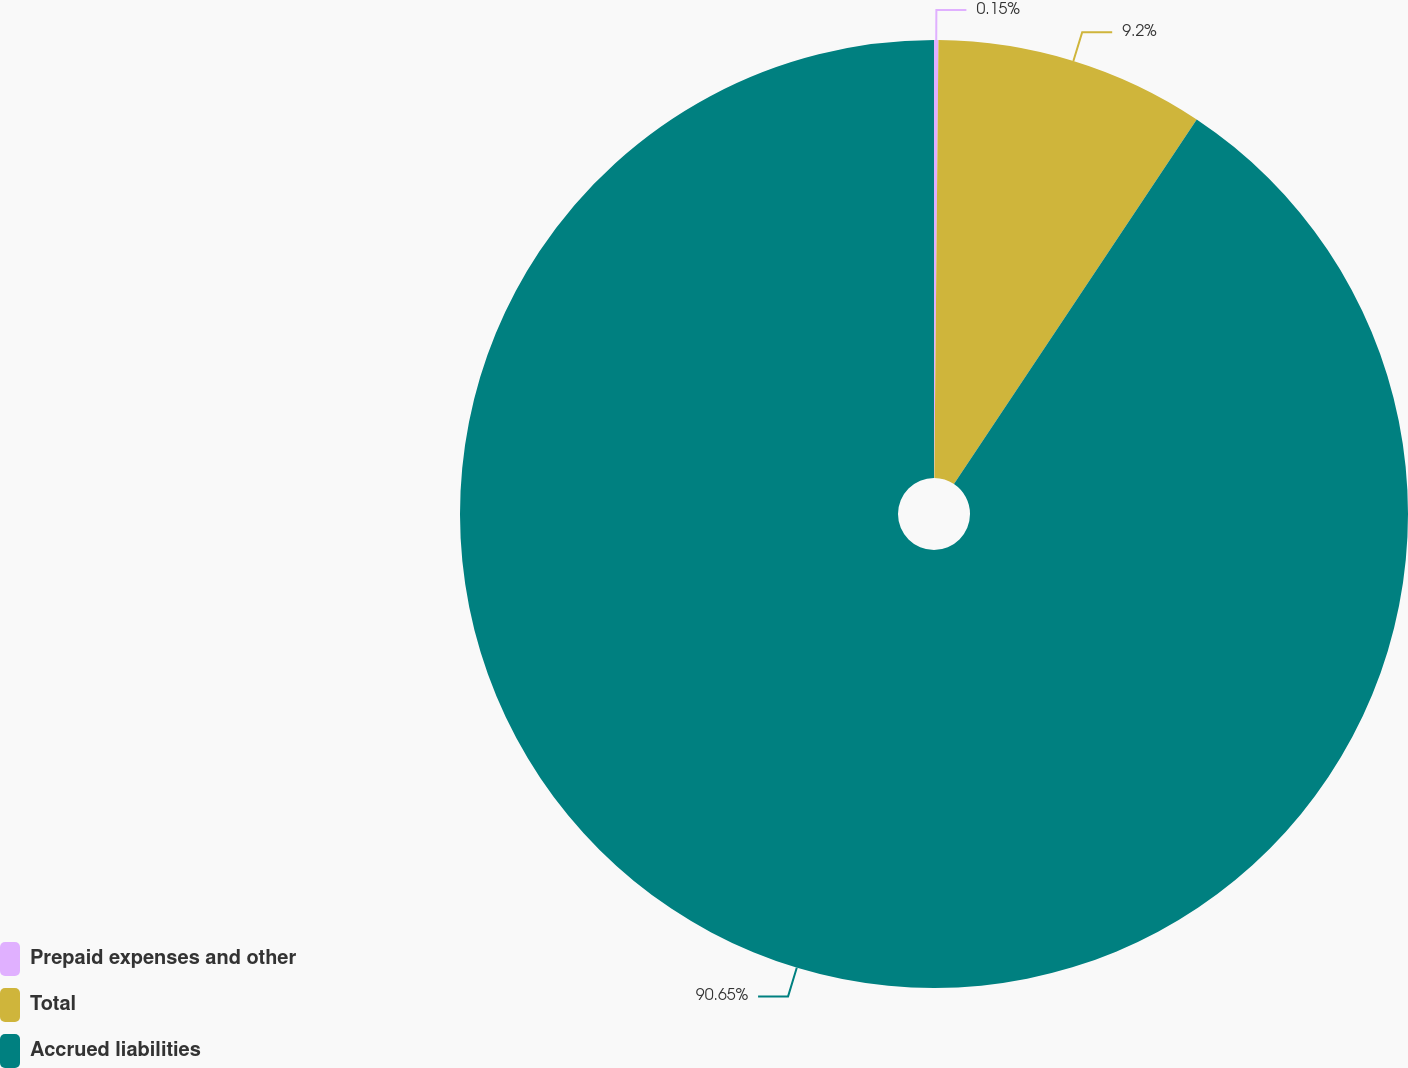Convert chart to OTSL. <chart><loc_0><loc_0><loc_500><loc_500><pie_chart><fcel>Prepaid expenses and other<fcel>Total<fcel>Accrued liabilities<nl><fcel>0.15%<fcel>9.2%<fcel>90.65%<nl></chart> 